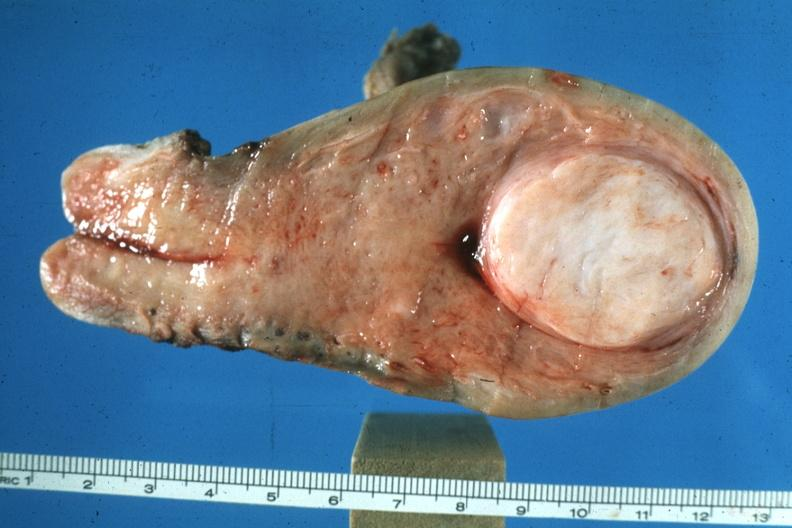what is present?
Answer the question using a single word or phrase. Uterus 